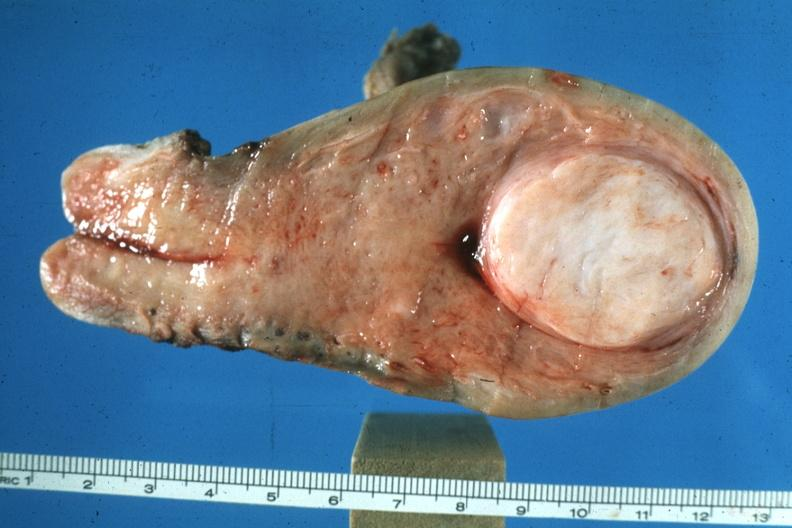what is present?
Answer the question using a single word or phrase. Uterus 